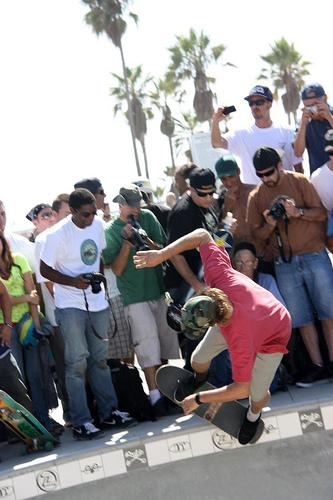What are people filming and taking pictures of? Please explain your reasoning. tricks. A person is doing a skateboard trick on the side of a cement surface. several people are holding cameras near a person doing a skateboarding trick. 